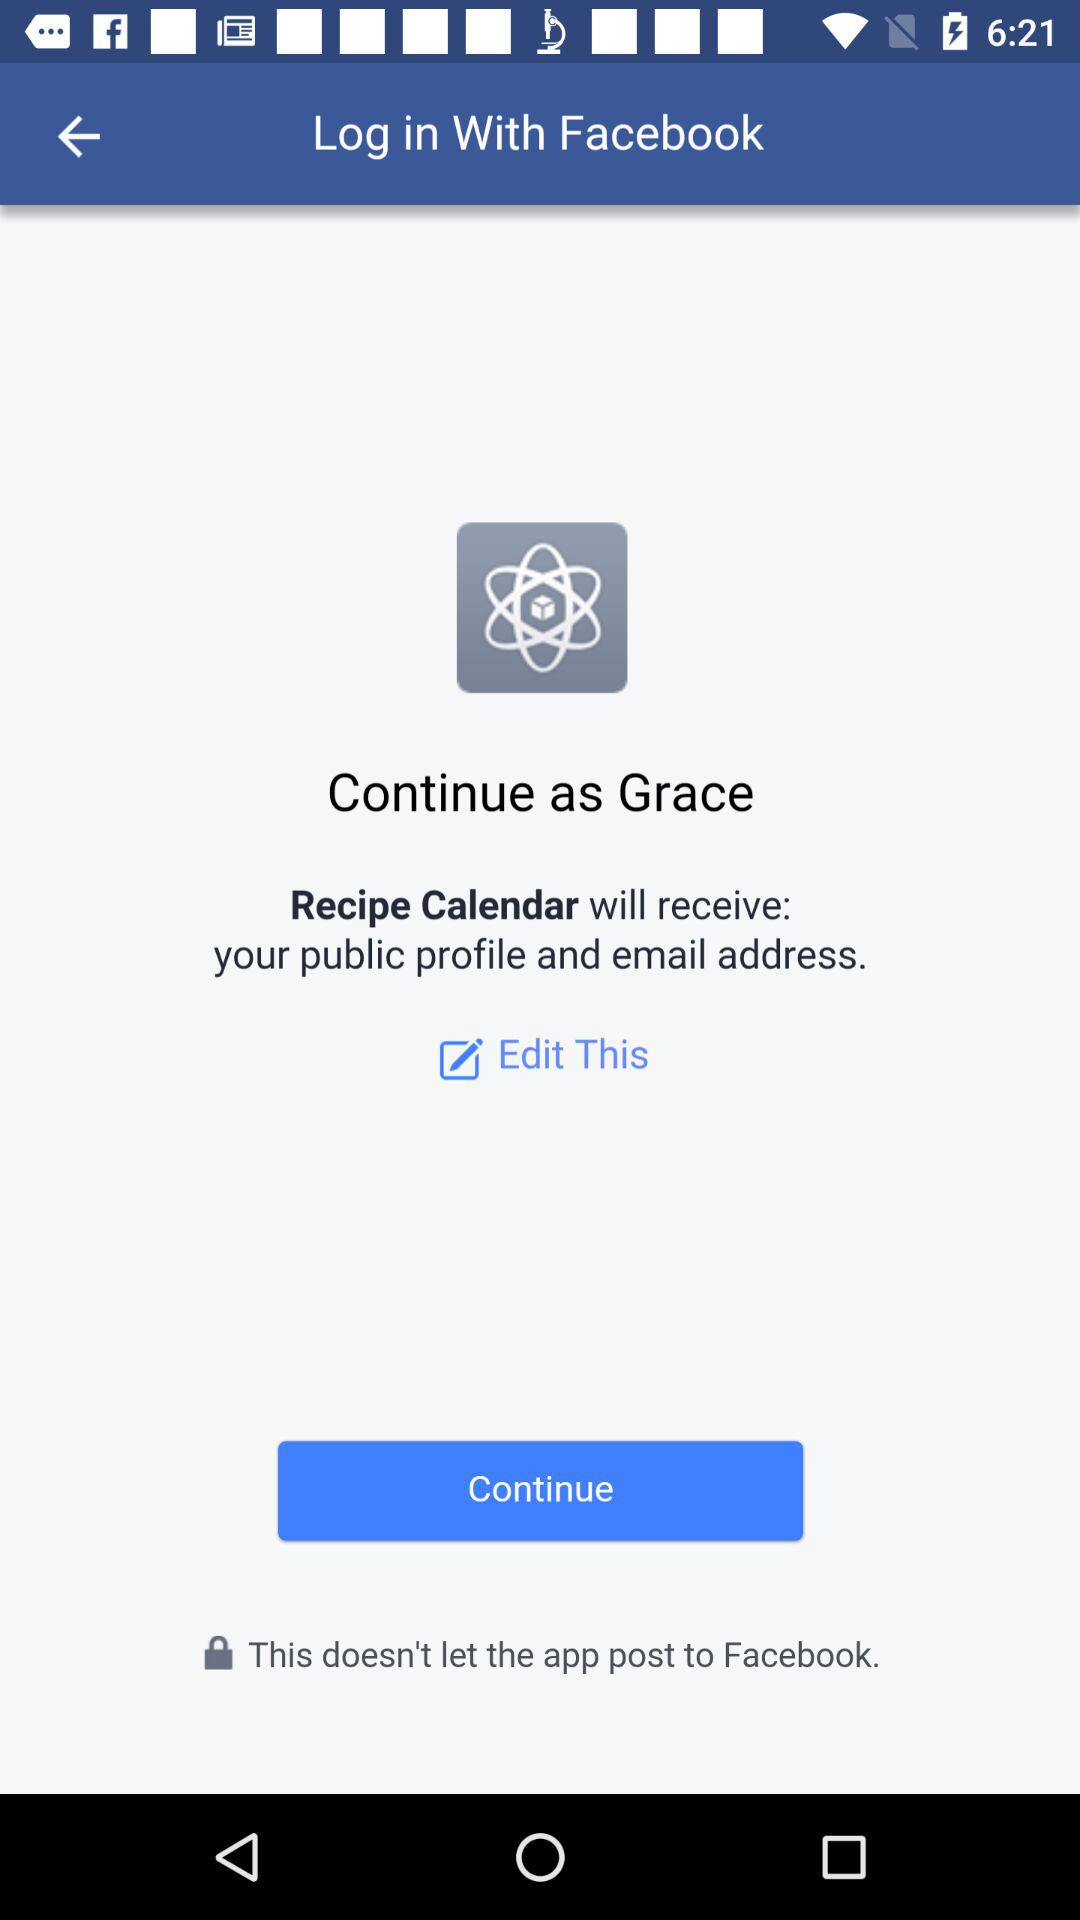What's the application name that will receive the public profile and email address? The application name that will receive the public profile and email address is "Recipe Calendar". 